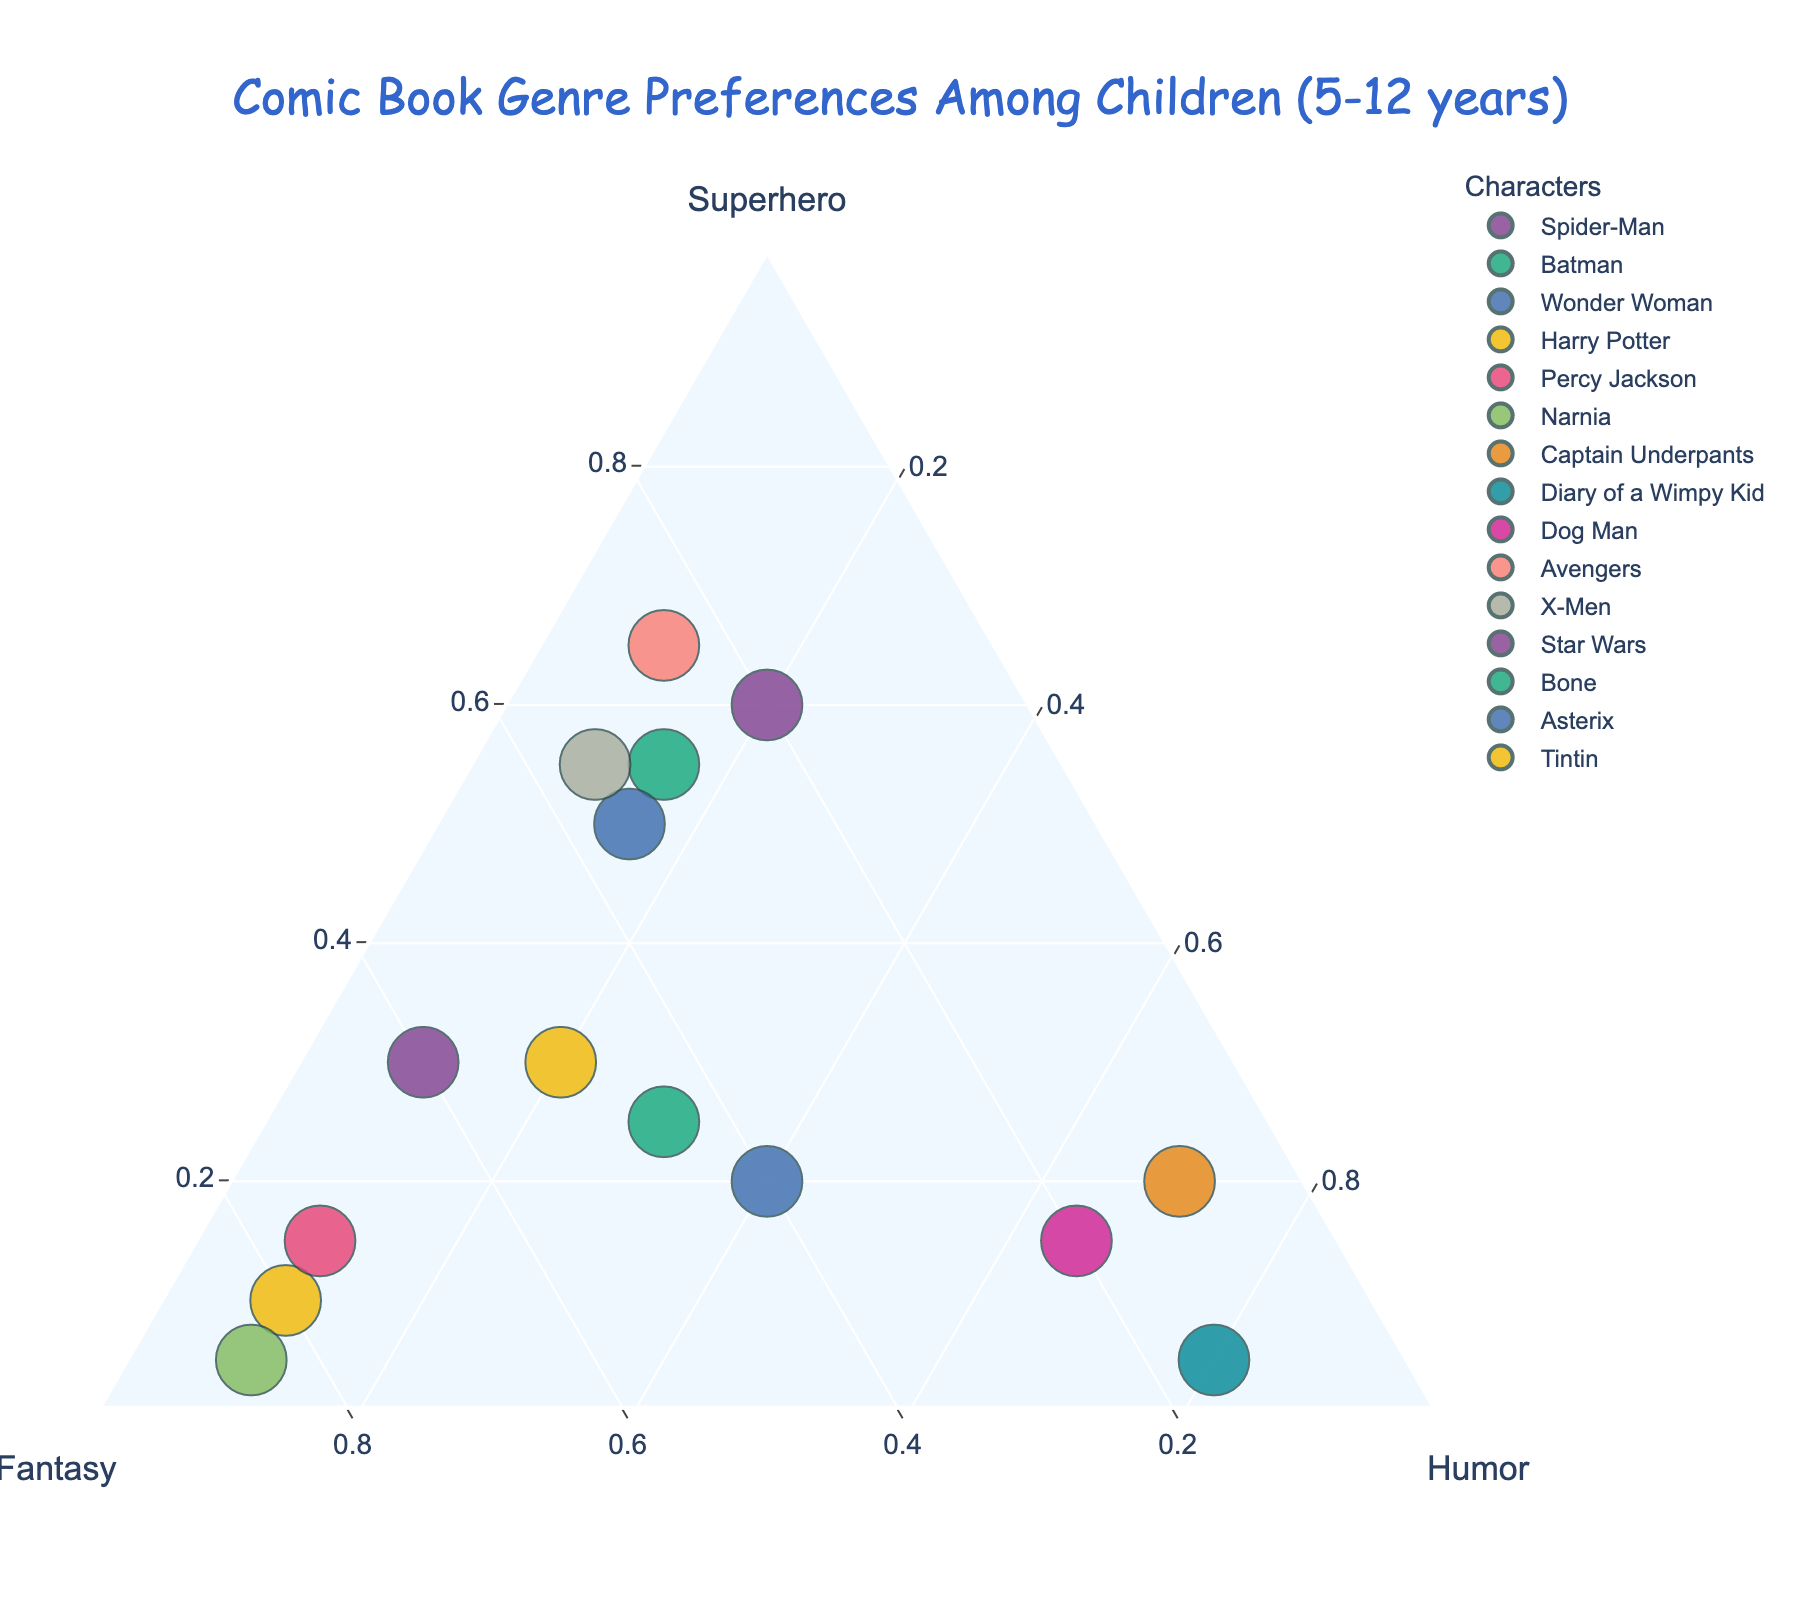What is the title of the ternary plot? The title is generally located at the top of the chart and is often larger or differently styled to make it stand out.
Answer: Comic Book Genre Preferences Among Children (5-12 years) How many characters prefer Superhero genre the most? To find this, we look for the data points closest to the Superhero axis. Characters like Spider-Man, Batman, Wonder Woman, Avengers, and X-Men fall into this category.
Answer: Five characters Which character has the highest preference for humor? We need to look at the data point closest to the Humor axis. For this dataset, the closest points are Captain Underpants, Diary of a Wimpy Kid, and Dog Man weighted towards humor.
Answer: Diary of a Wimpy Kid What is the average Humor preference of Harry Potter, Percy Jackson, and Narnia combined? Add the Humor values of Harry Potter (10), Percy Jackson (10), and Narnia (10), and then divide by 3. (10 + 10 + 10) / 3 = 10.
Answer: 10 Which character's genre preferences are almost equally divided among all three genres? We need to identify the data point positioned closest to the center of the ternary plot, representing roughly equal Superhero, Fantasy, and Humor values.
Answer: Asterix Compare the Superhero preference between Spider-Man and Batman. Which character has a higher preference and by how much? Look at the Superhero values of Spider-Man (60) and Batman (55). The difference is: 60 - 55 = 5.
Answer: Spider-Man by 5 What is the combined Fantasy preference for Star Wars and Tintin? Sum the Fantasy preferences of Star Wars (60) and Tintin (50). 60 + 50 = 110.
Answer: 110 How does the preference distribution for Dog Man compare to Captain Underpants in terms of humor? Compare the Humor values: Dog Man has 65 and Captain Underpants has 70. Captain Underpants wins by a margin of 5.
Answer: Captain Underpants by 5 Which character has the most skewed preference towards Fantasy genre? Look for the point positioned nearest to the Fantasy axis. For this dataset, Harry Potter, Percy Jackson, and Narnia are the most weighted towards Fantasy. Narnia has the highest value (85).
Answer: Narnia Among X-Men, Avengers, and Wonder Woman, who has the highest combined preference for Superhero and Fantasy genres? Sum the Superhero and Fantasy values:
- X-Men: 55 + 35 = 90
- Avengers: 65 + 25 = 90
- Wonder Woman: 50 + 35 = 85
Both X-Men and Avengers have the highest combined value of 90 each.
Answer: X-Men and Avengers 